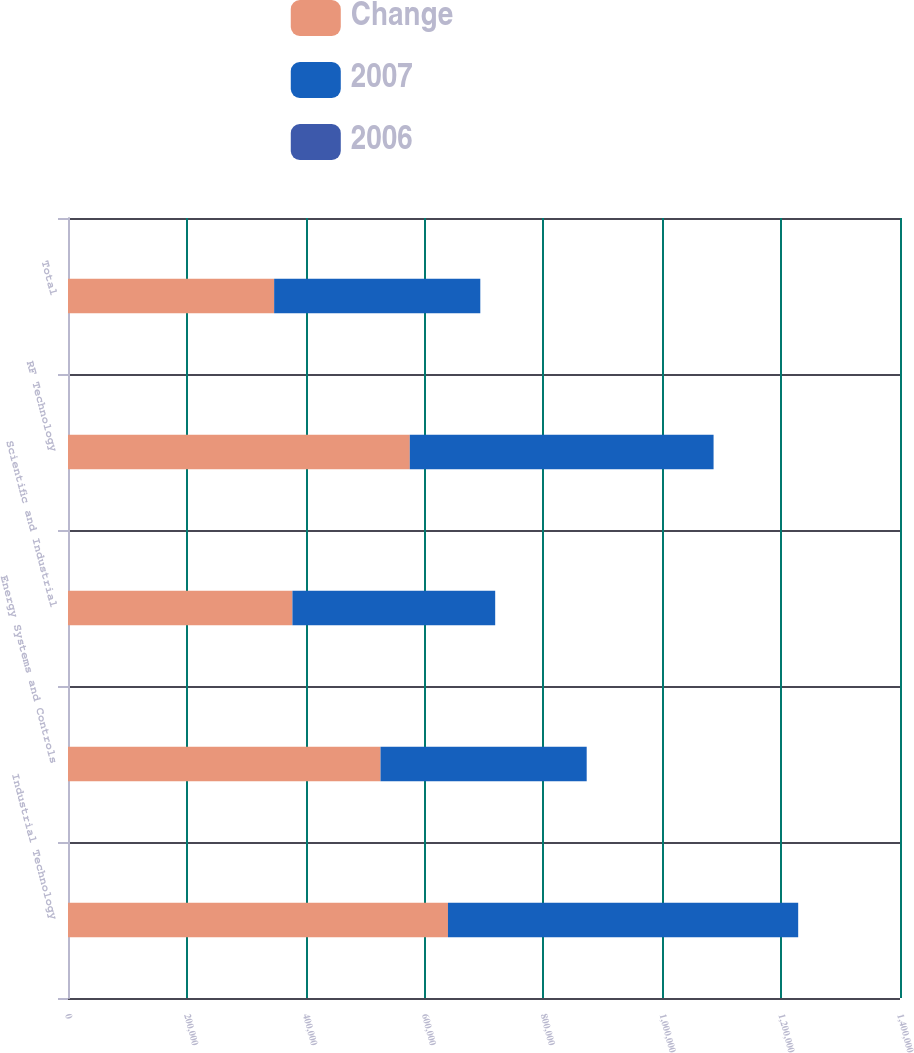<chart> <loc_0><loc_0><loc_500><loc_500><stacked_bar_chart><ecel><fcel>Industrial Technology<fcel>Energy Systems and Controls<fcel>Scientific and Industrial<fcel>RF Technology<fcel>Total<nl><fcel>Change<fcel>639348<fcel>525899<fcel>377653<fcel>575100<fcel>346880<nl><fcel>2007<fcel>589322<fcel>346880<fcel>341178<fcel>511188<fcel>346880<nl><fcel>2006<fcel>8.5<fcel>51.6<fcel>10.7<fcel>12.5<fcel>18.4<nl></chart> 